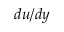Convert formula to latex. <formula><loc_0><loc_0><loc_500><loc_500>{ d u } / { d y }</formula> 